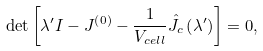<formula> <loc_0><loc_0><loc_500><loc_500>\det \left [ { \lambda ^ { \prime } { I } - { J } ^ { \left ( 0 \right ) } - \frac { 1 } { V _ { c e l l } } { \hat { J } } _ { c } \left ( { \lambda ^ { \prime } } \right ) } \right ] = 0 ,</formula> 